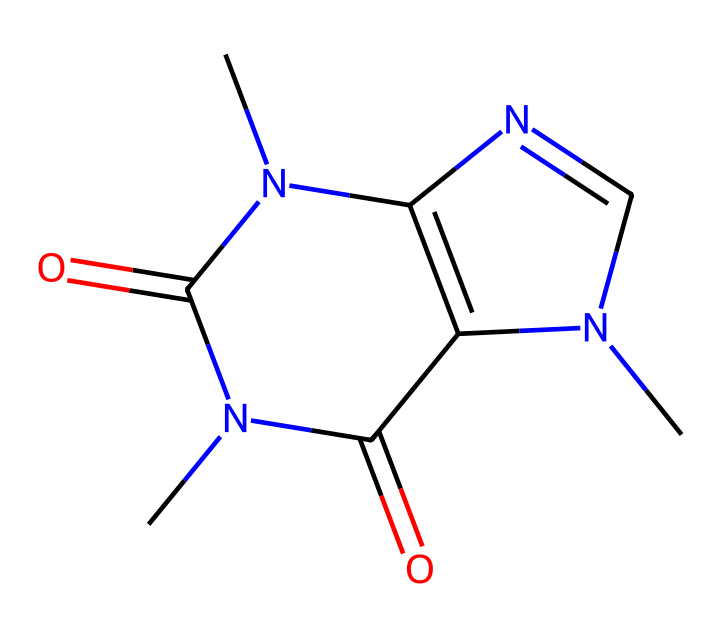What is the molecular formula of caffeine? By analyzing the atomic composition of the chemical structure represented by the SMILES, we can count the number of carbon (C), hydrogen (H), nitrogen (N), and oxygen (O) atoms. Caffeine contains 8 carbon atoms, 10 hydrogen atoms, 4 nitrogen atoms, and 2 oxygen atoms, leading to the molecular formula C8H10N4O2.
Answer: C8H10N4O2 How many rings are present in the structure of caffeine? Upon examining the structure, there are two fused rings present in caffeine. The cyclic nature of the molecule is evident from the multiple connections between atoms, forming a bicyclic structure.
Answer: 2 Which element is primarily responsible for caffeine's stimulating properties? The nitrogen atoms in the structure, particularly in the context of how they interact with receptors in the brain, are primarily responsible for caffeine's stimulating properties. The presence of nitrogen is characteristic of many stimulants.
Answer: nitrogen What type of compound is caffeine classified as? Caffeine is classified as an alkaloid due to its complex nitrogen-containing structure and pharmacological effects. Alkaloids often have significant biological activity and are commonly found in plants.
Answer: alkaloid How many nitrogen atoms are in caffeine? By inspecting the chemical representation, we can see that there are four nitrogen atoms integrated into the structure of caffeine. This is crucial for its function and classification.
Answer: 4 What functional groups are present in caffeine? The structure of caffeine contains both amine (from the nitrogen atoms) and carbonyl (from the double-bonded oxygen) functional groups, indicating its behavior as a biological molecule.
Answer: amine and carbonyl What is the significance of the carbonyl groups in caffeine? The carbonyl groups contribute to the reactivity and solubility of caffeine in biological systems, influencing how it interacts with enzymes and receptors in the body. This structural feature is crucial for its metabolic processes.
Answer: reactivity and solubility 